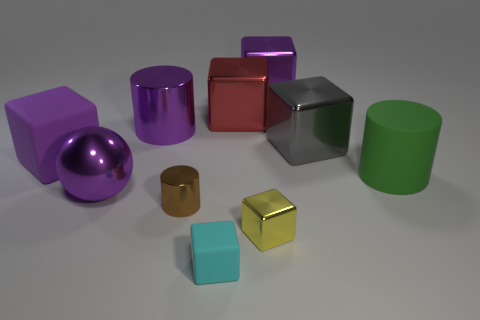Subtract all gray cubes. How many cubes are left? 5 Subtract all small matte cubes. How many cubes are left? 5 Subtract all blue cubes. Subtract all blue cylinders. How many cubes are left? 6 Subtract all blocks. How many objects are left? 4 Subtract 2 purple cubes. How many objects are left? 8 Subtract all tiny metal cylinders. Subtract all green rubber cylinders. How many objects are left? 8 Add 5 purple cubes. How many purple cubes are left? 7 Add 2 brown cylinders. How many brown cylinders exist? 3 